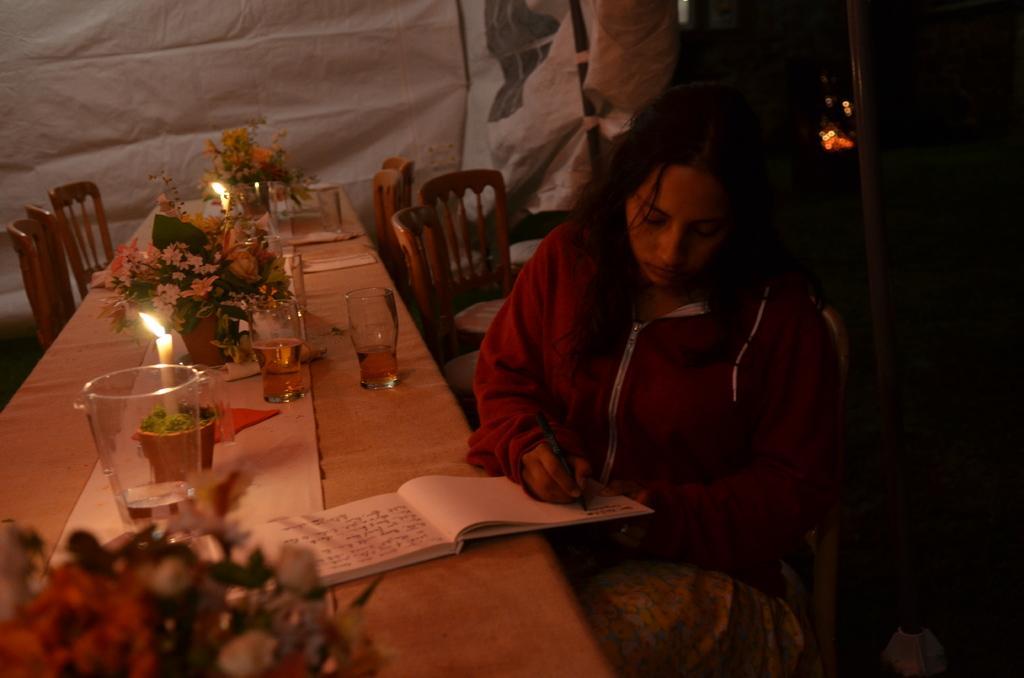Describe this image in one or two sentences. In front of the image there is a person sitting on the chair and she is holding the book and a pen. Behind her there are a few chairs. In front of her there is a table. On top of it there are flower pots, glasses, candles. In the background of the image there is a banner. On the right side of the image there is a pole. 